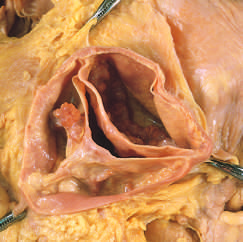does one cusp have a partial fusion at its center?
Answer the question using a single word or phrase. Yes 